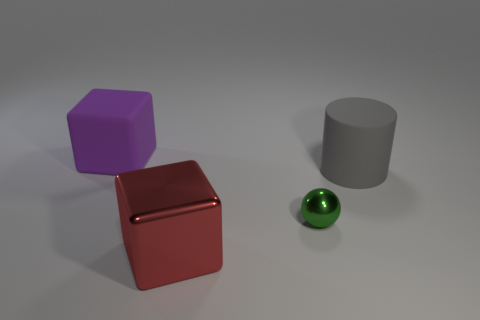Add 3 cylinders. How many objects exist? 7 Subtract 1 cylinders. How many cylinders are left? 0 Subtract all cylinders. How many objects are left? 3 Add 4 green cubes. How many green cubes exist? 4 Subtract 0 red spheres. How many objects are left? 4 Subtract all purple spheres. Subtract all gray cylinders. How many spheres are left? 1 Subtract all red objects. Subtract all small things. How many objects are left? 2 Add 1 gray cylinders. How many gray cylinders are left? 2 